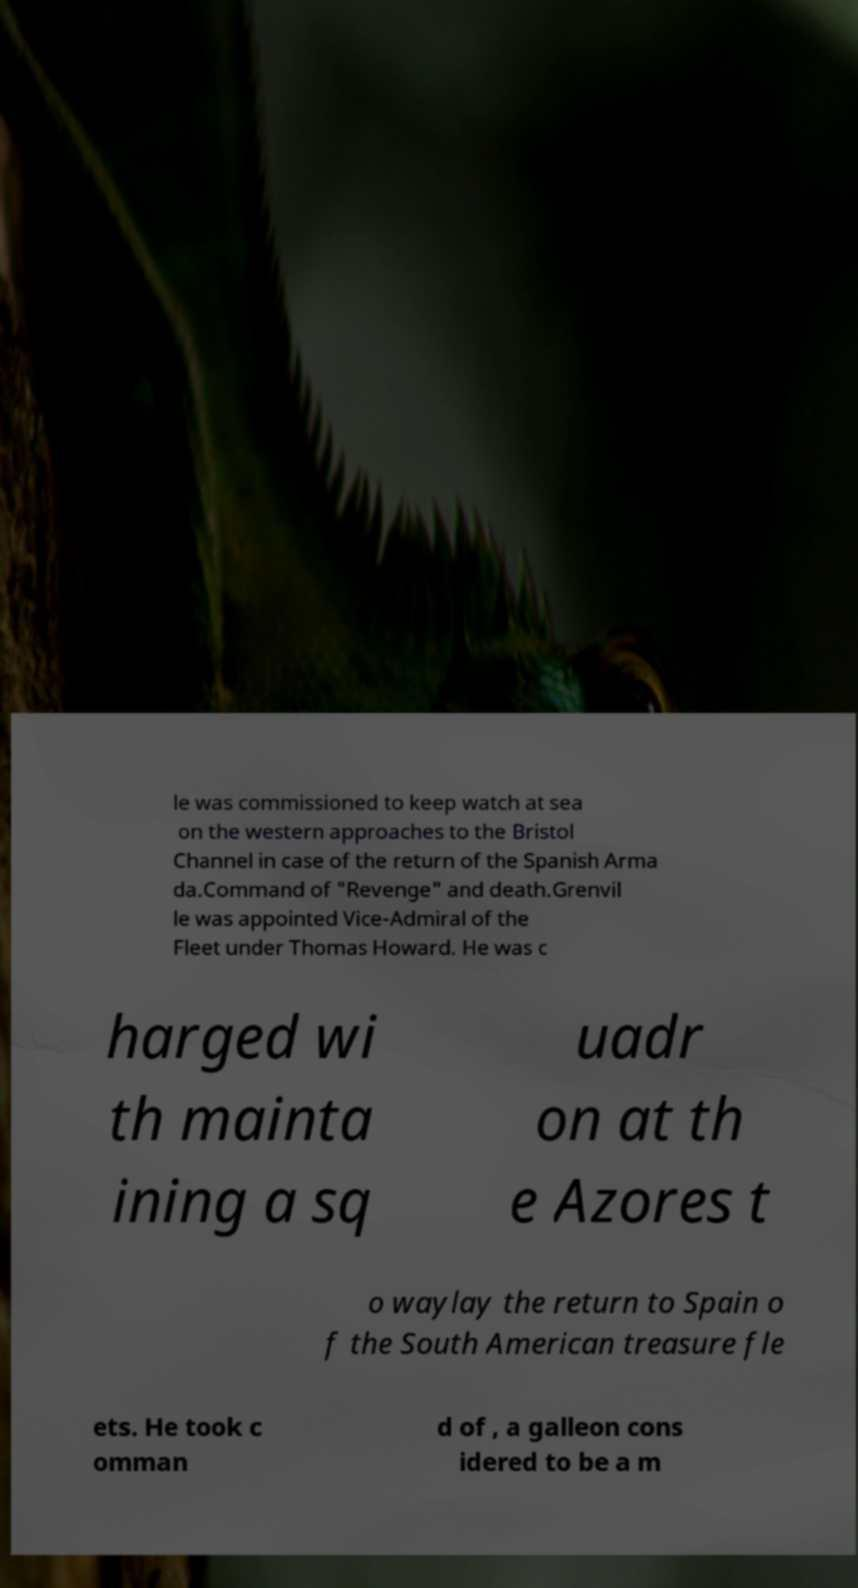What messages or text are displayed in this image? I need them in a readable, typed format. le was commissioned to keep watch at sea on the western approaches to the Bristol Channel in case of the return of the Spanish Arma da.Command of "Revenge" and death.Grenvil le was appointed Vice-Admiral of the Fleet under Thomas Howard. He was c harged wi th mainta ining a sq uadr on at th e Azores t o waylay the return to Spain o f the South American treasure fle ets. He took c omman d of , a galleon cons idered to be a m 